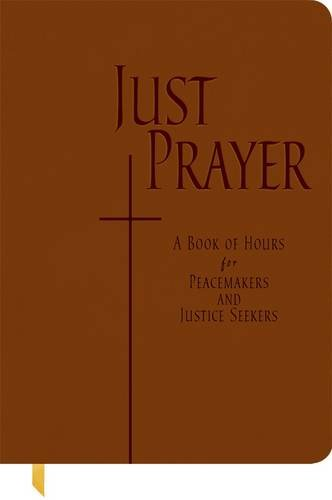What themes are explored in this book? The book explores themes such as social justice, peace, and spiritual devotion, aiming to integrate prayer into daily actions for societal change. 